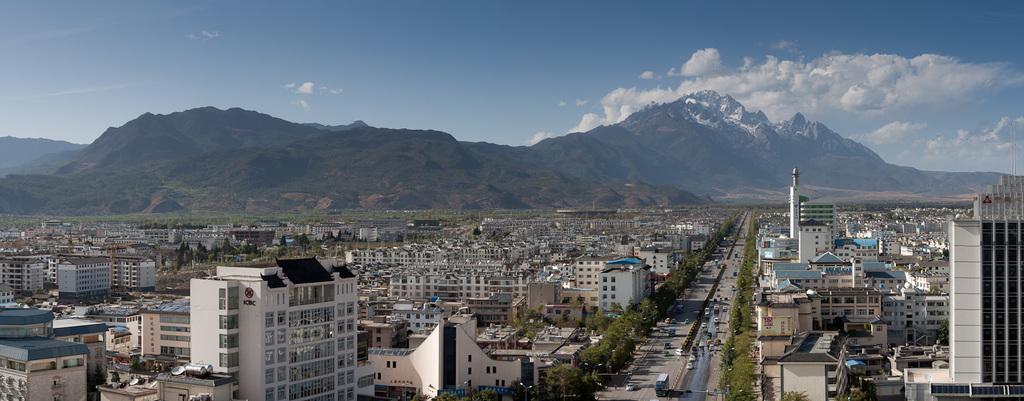Please provide a concise description of this image. In this image I can see in the middle few vehicles are moving on the road, There are trees on either side of this road, there are buildings. At the back side there are hills, at the top it is the sky. 